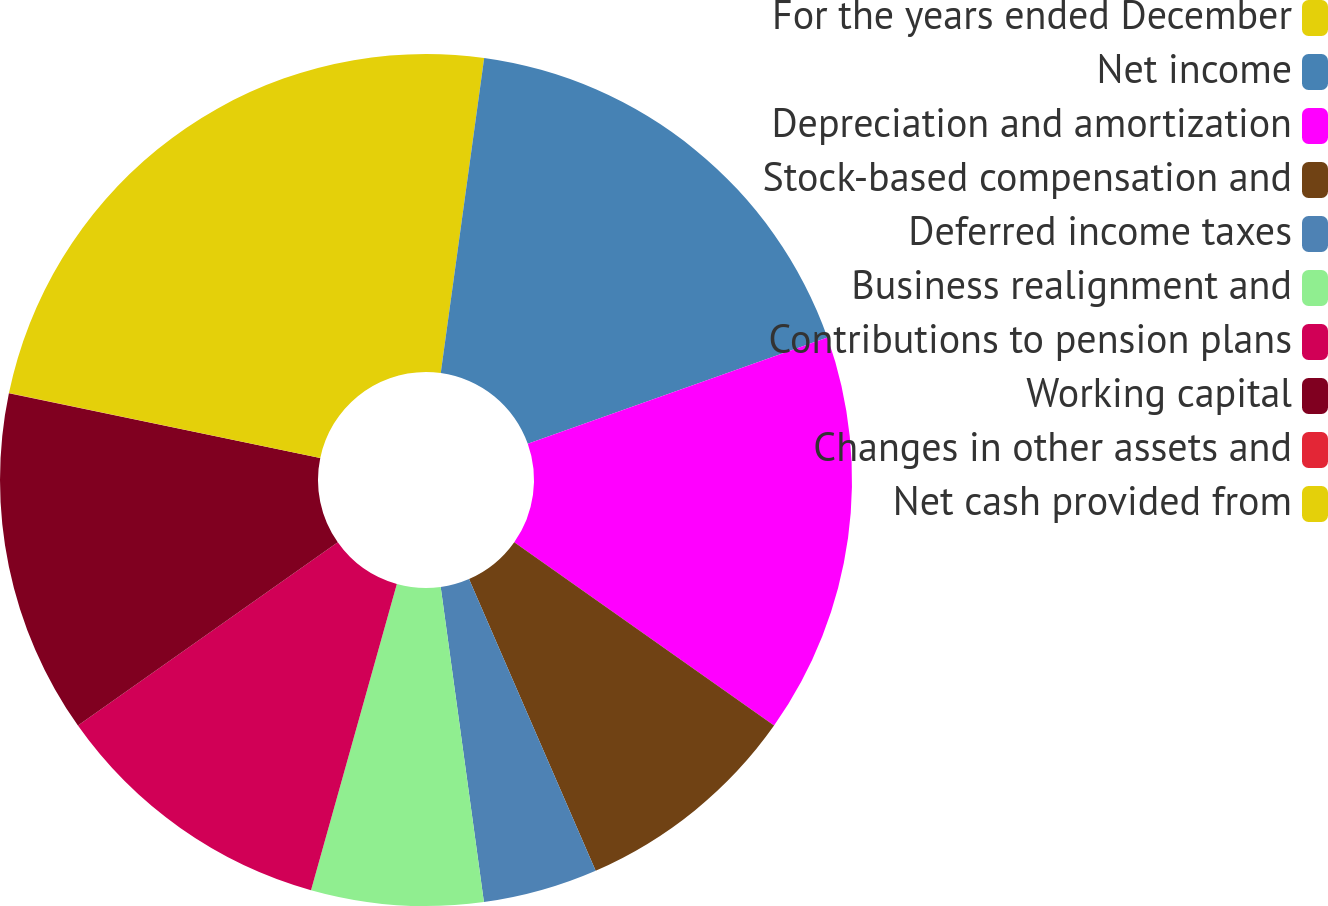<chart> <loc_0><loc_0><loc_500><loc_500><pie_chart><fcel>For the years ended December<fcel>Net income<fcel>Depreciation and amortization<fcel>Stock-based compensation and<fcel>Deferred income taxes<fcel>Business realignment and<fcel>Contributions to pension plans<fcel>Working capital<fcel>Changes in other assets and<fcel>Net cash provided from<nl><fcel>2.18%<fcel>17.39%<fcel>15.21%<fcel>8.7%<fcel>4.35%<fcel>6.52%<fcel>10.87%<fcel>13.04%<fcel>0.01%<fcel>21.73%<nl></chart> 